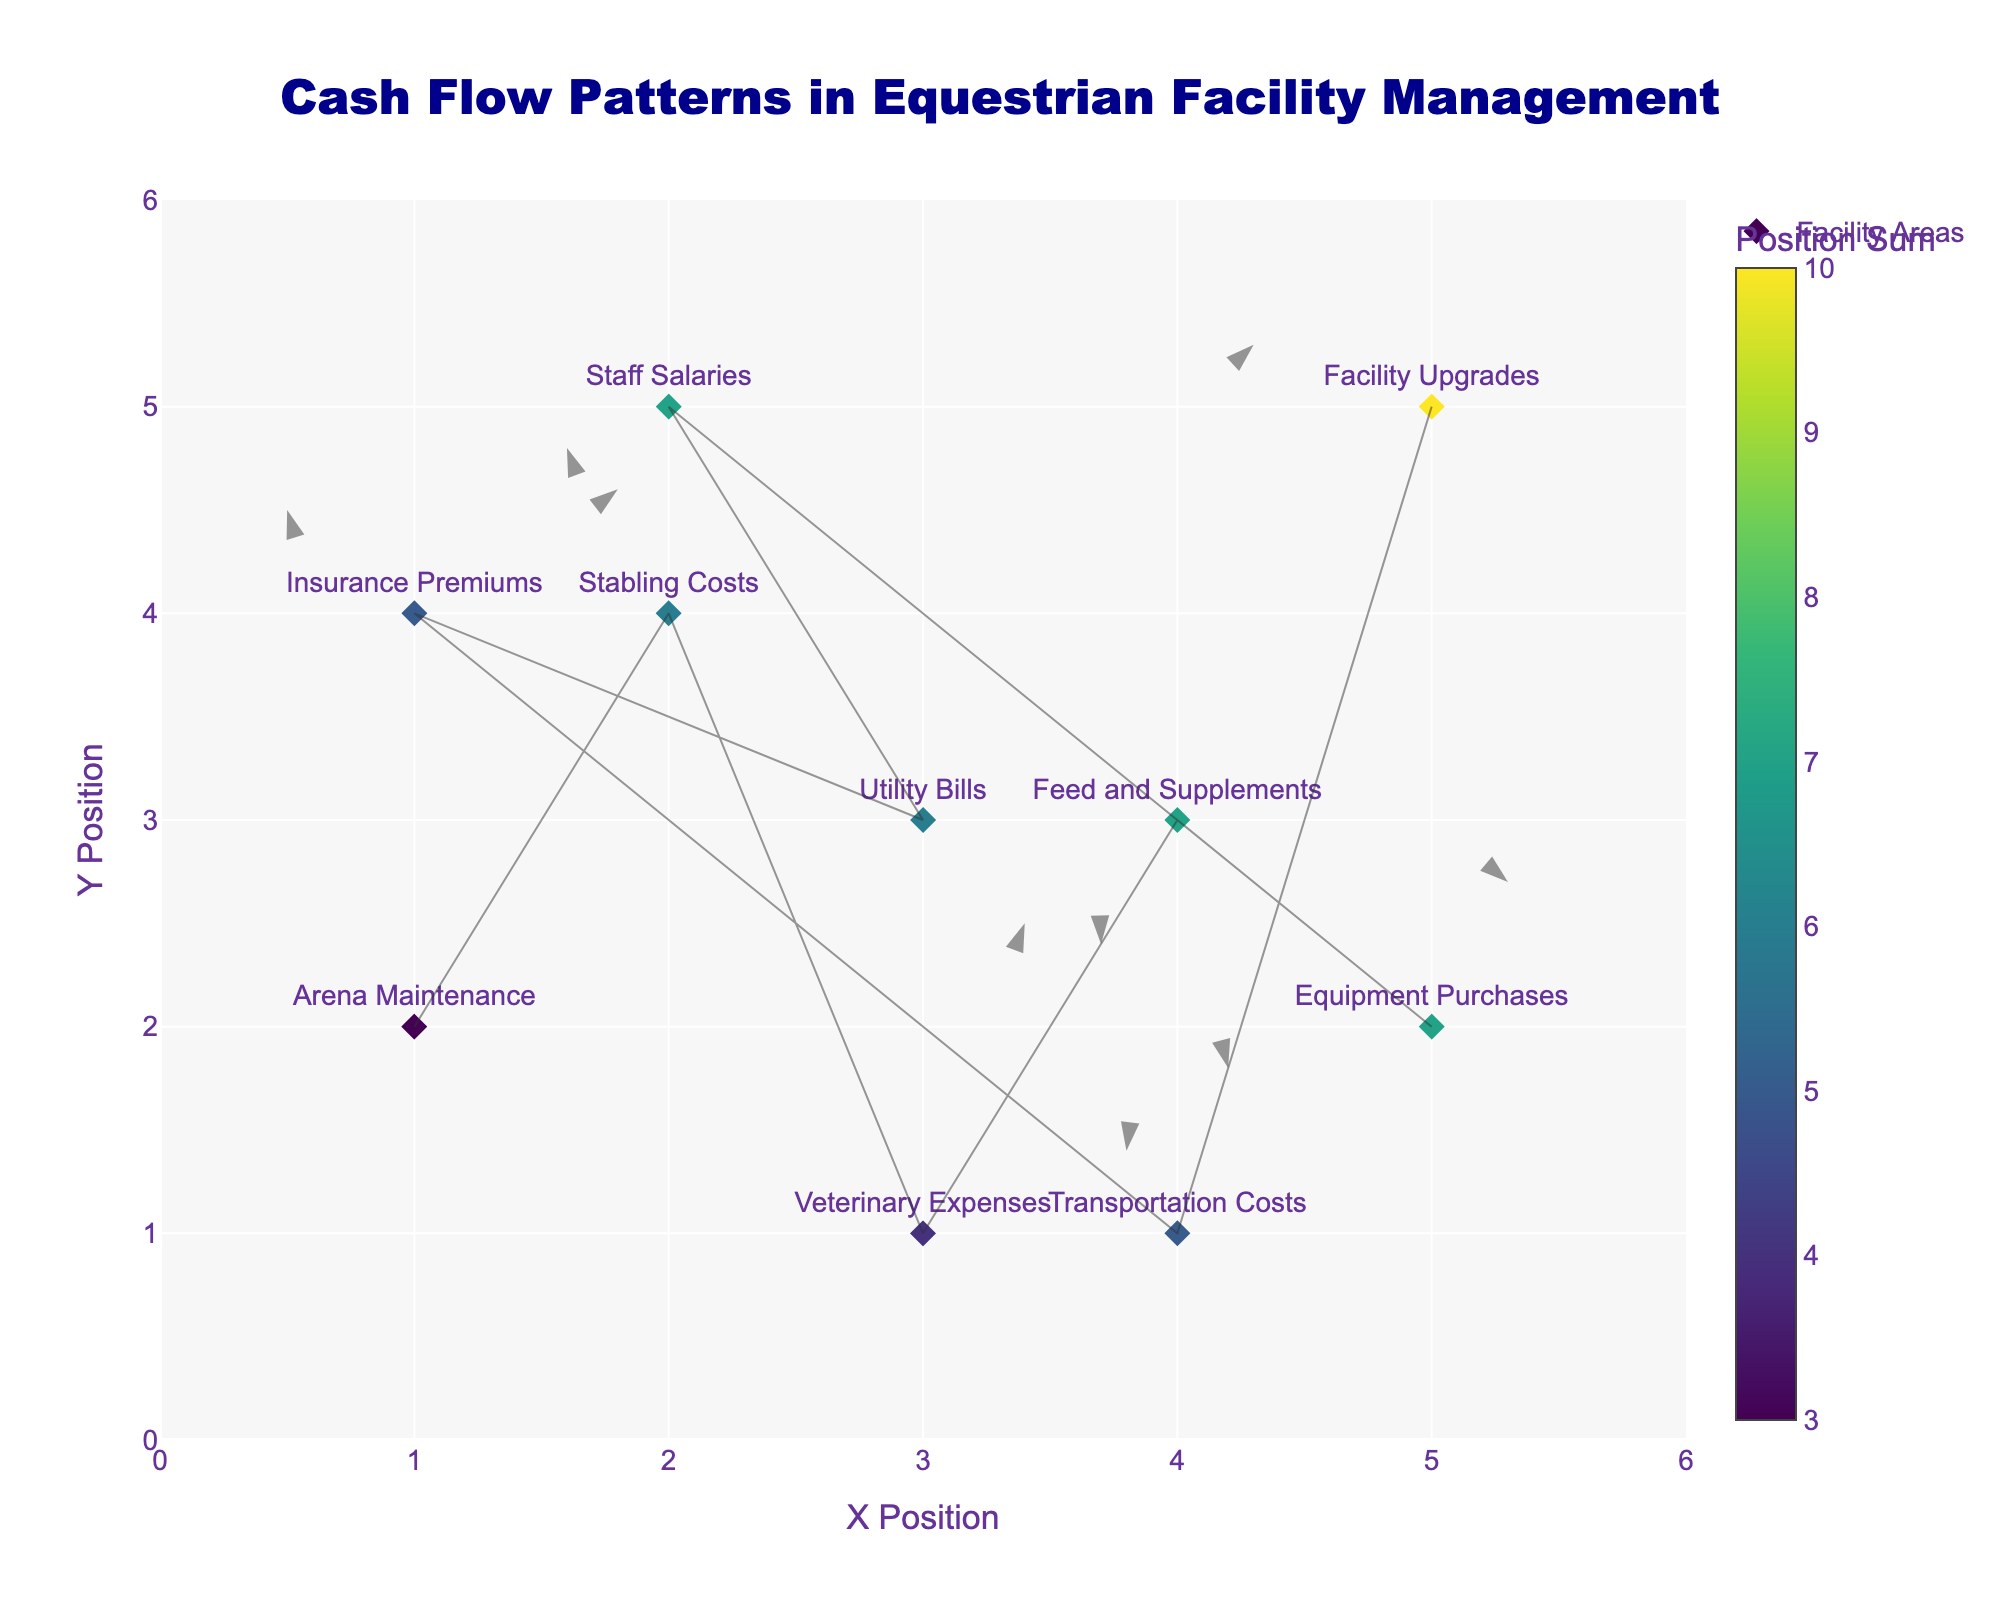What's the title of the figure? The title of the figure is located at the top and is clearly stated.
Answer: "Cash Flow Patterns in Equestrian Facility Management" What are the labels for the X and Y axes? The X and Y axis titles are located along the respective axes and are clearly stated.
Answer: "X Position" and "Y Position" How many data points are in the figure? Each marker on the quiver plot represents one data point.
Answer: 10 Which facility area has a negative U component? By examining the U components and matching them with their respective facility areas, we see that "Stabling Costs" has a U value of -0.2, "Feed and Supplements" has a U value of -0.6, "Staff Salaries" has a U value of -0.4, "Insurance Premiums" has a U value of -0.5, and "Facility Upgrades" has a U value of -0.7.
Answer: "Stabling Costs", "Feed and Supplements", "Staff Salaries", "Insurance Premiums", "Facility Upgrades" What is the sum of the V components for "Stabling Costs" and "Utility Bills"? Identify the V components for "Stabling Costs" (0.6) and "Utility Bills" (-0.6) and sum them up: 0.6 + (-0.6) = 0
Answer: 0 Which facility area has the largest positive Y movement? The facility area with the highest positive V component corresponds to "Transportation Costs" with a V value of 0.8.
Answer: "Transportation Costs" Compare the directions of cash flow for "Arena Maintenance" and "Feed and Supplements" - how do they differ? The direction of each arrow is determined by the U and V components. "Arena Maintenance" has a positive U and negative V (0.5, -0.3), while "Feed and Supplements" has negative U and V components (-0.6, -0.5). This indicates that "Arena Maintenance" moves slightly right and downwards, while "Feed and Supplements" moves left and downwards.
Answer: "Arena Maintenance" moves towards the right and down, while "Feed and Supplements" moves left and down What is the average X-position of all the facility areas? Sum the X positions and divide by the number of facility areas: (1+2+3+4+5+2+3+1+4+5) / 10 = 3
Answer: 3 Which facility area has the smallest X-position? Compare the X positions and identify the smallest one. "Arena Maintenance" and "Insurance Premiums" have the smallest X position of 1.
Answer: "Arena Maintenance" and "Insurance Premiums" If you combine the X and Y position of "Equipment Purchases," where does it lie compared to other facility areas? Sum the X and Y positions for "Equipment Purchases" (5+2 = 7) and compare it to other combinations.
Answer: It is one of the highest combined positions (7) 